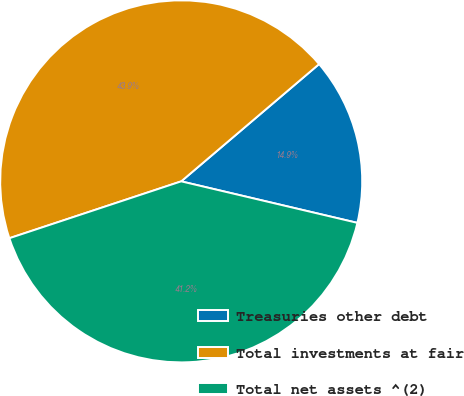<chart> <loc_0><loc_0><loc_500><loc_500><pie_chart><fcel>Treasuries other debt<fcel>Total investments at fair<fcel>Total net assets ^(2)<nl><fcel>14.9%<fcel>43.87%<fcel>41.23%<nl></chart> 